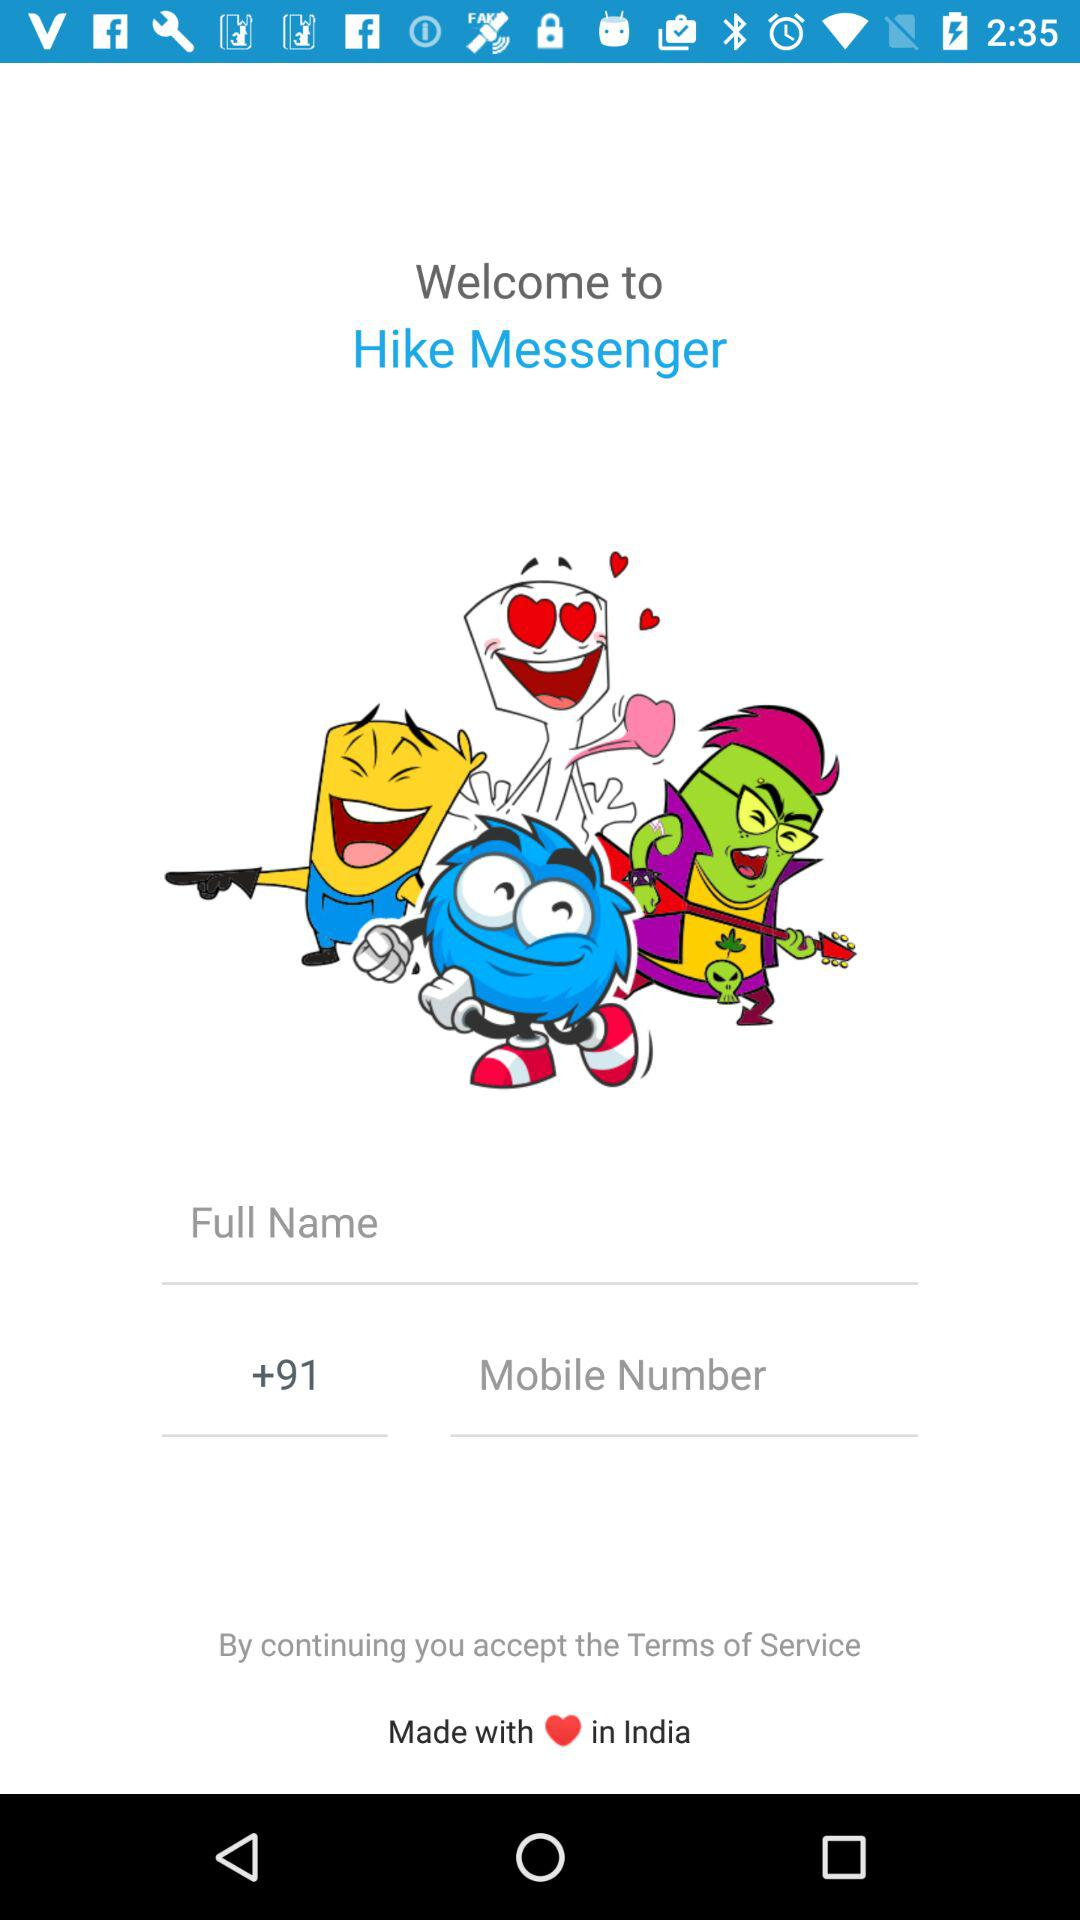What is the country code? The country code is +91. 